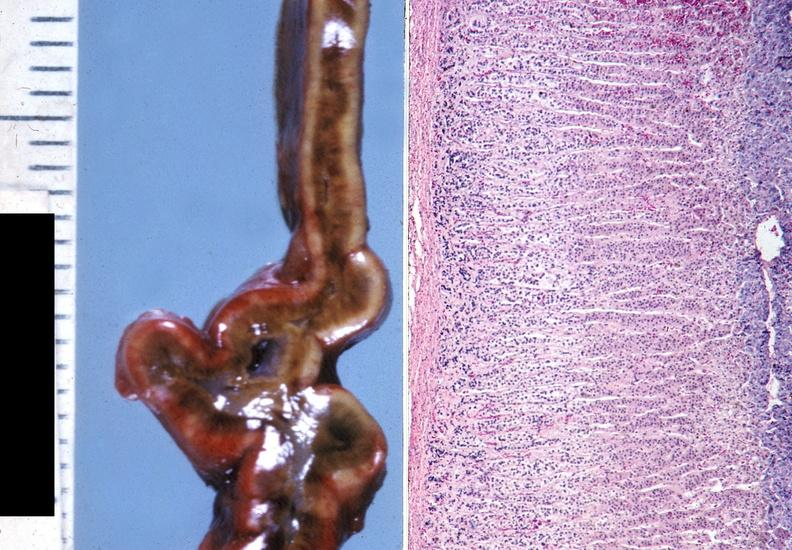where does this belong to?
Answer the question using a single word or phrase. Endocrine system 